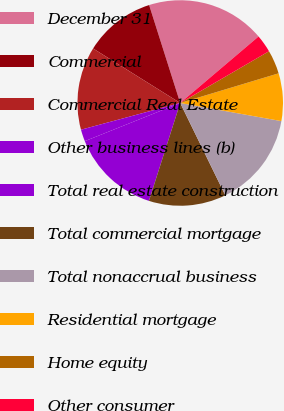<chart> <loc_0><loc_0><loc_500><loc_500><pie_chart><fcel>December 31<fcel>Commercial<fcel>Commercial Real Estate<fcel>Other business lines (b)<fcel>Total real estate construction<fcel>Total commercial mortgage<fcel>Total nonaccrual business<fcel>Residential mortgage<fcel>Home equity<fcel>Other consumer<nl><fcel>18.69%<fcel>11.21%<fcel>13.08%<fcel>1.87%<fcel>14.02%<fcel>12.15%<fcel>14.95%<fcel>7.48%<fcel>3.74%<fcel>2.8%<nl></chart> 